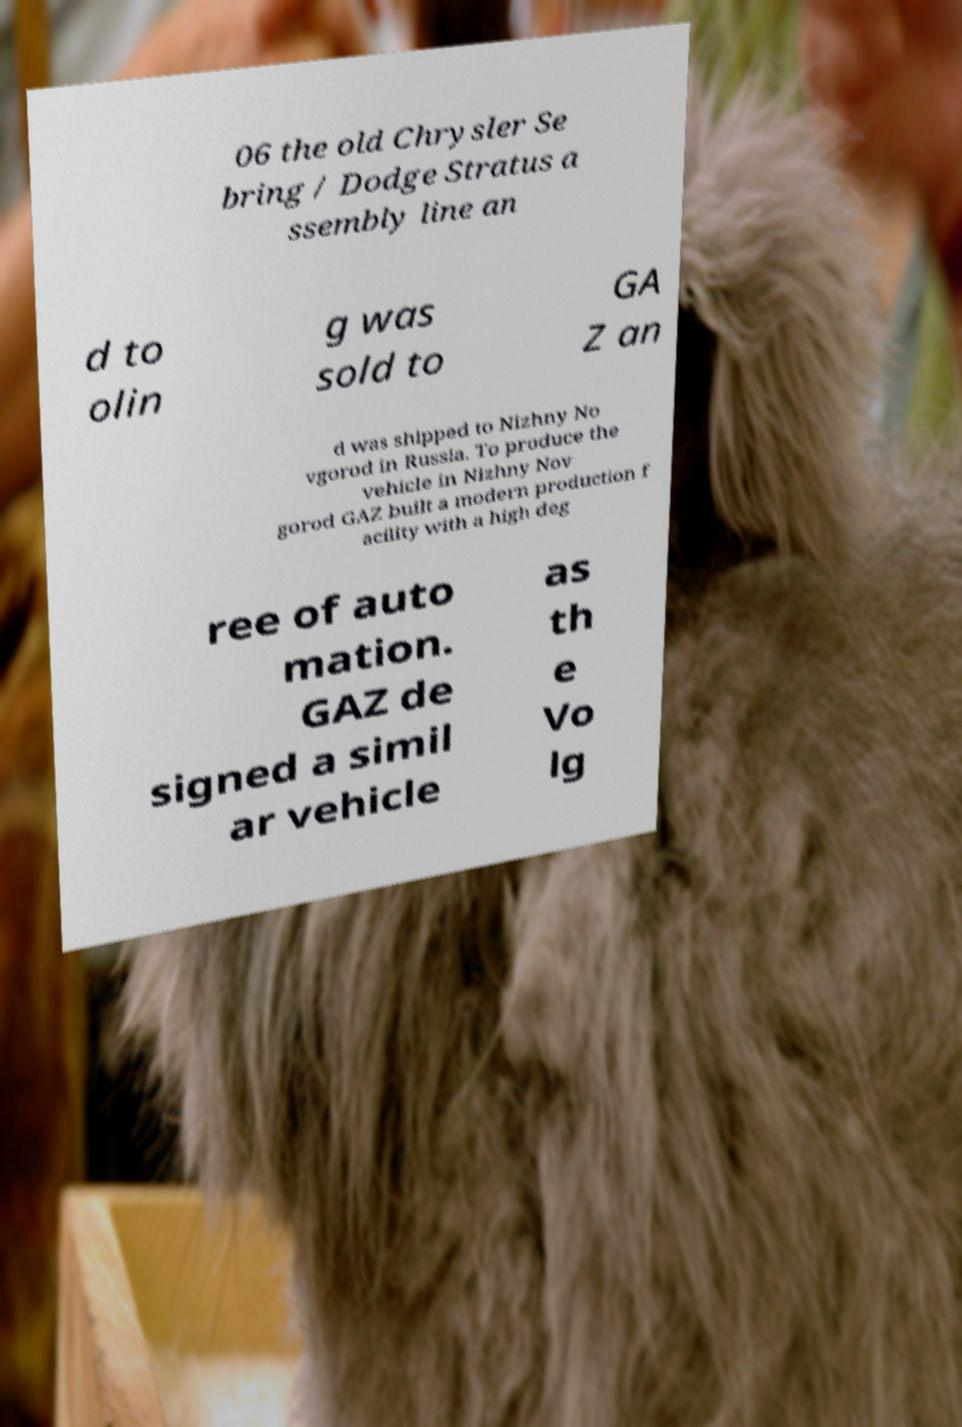There's text embedded in this image that I need extracted. Can you transcribe it verbatim? 06 the old Chrysler Se bring / Dodge Stratus a ssembly line an d to olin g was sold to GA Z an d was shipped to Nizhny No vgorod in Russia. To produce the vehicle in Nizhny Nov gorod GAZ built a modern production f acility with a high deg ree of auto mation. GAZ de signed a simil ar vehicle as th e Vo lg 